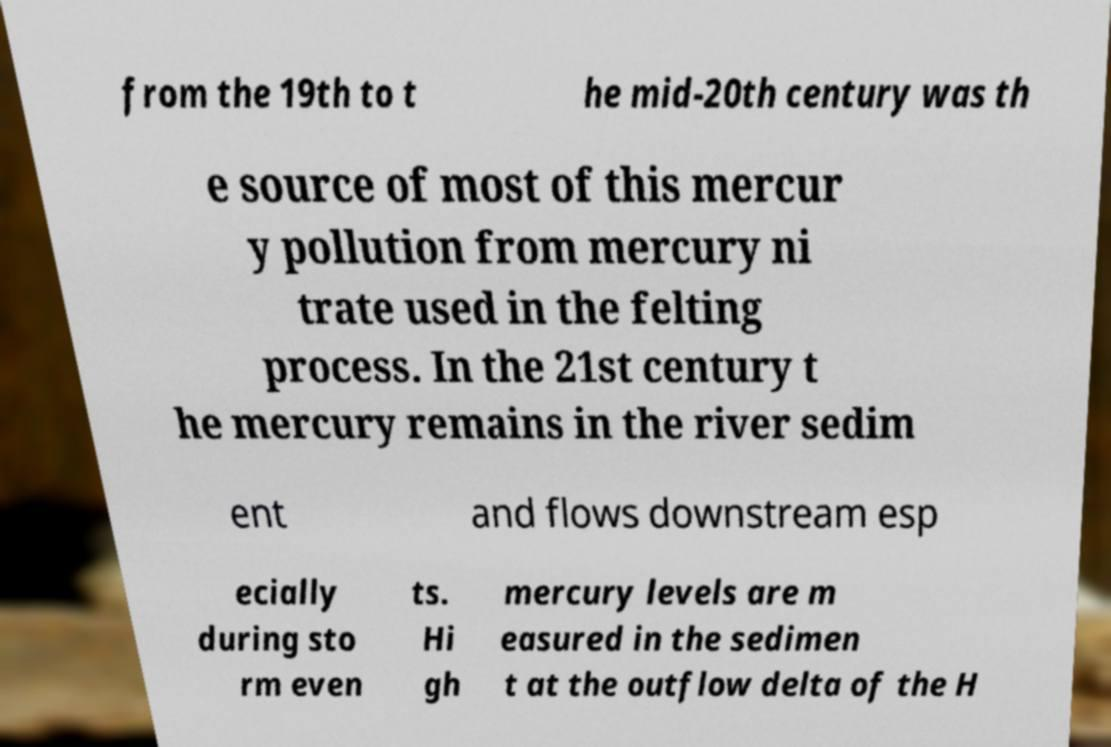Please identify and transcribe the text found in this image. from the 19th to t he mid-20th century was th e source of most of this mercur y pollution from mercury ni trate used in the felting process. In the 21st century t he mercury remains in the river sedim ent and flows downstream esp ecially during sto rm even ts. Hi gh mercury levels are m easured in the sedimen t at the outflow delta of the H 